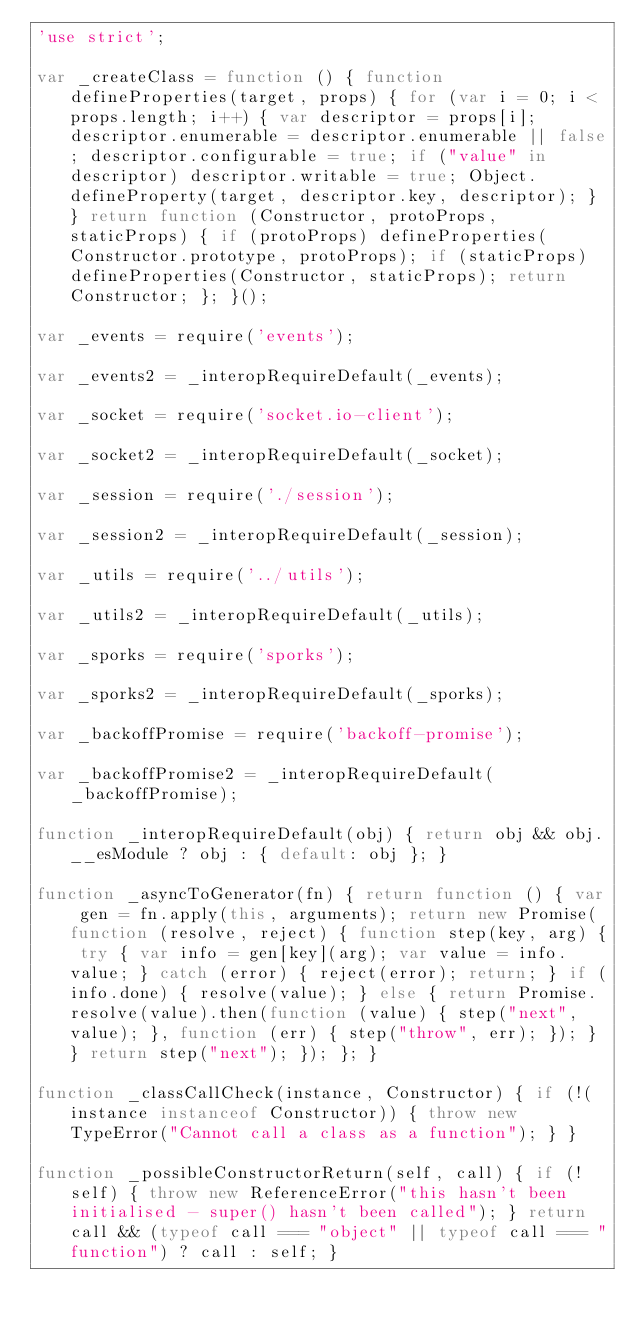Convert code to text. <code><loc_0><loc_0><loc_500><loc_500><_JavaScript_>'use strict';

var _createClass = function () { function defineProperties(target, props) { for (var i = 0; i < props.length; i++) { var descriptor = props[i]; descriptor.enumerable = descriptor.enumerable || false; descriptor.configurable = true; if ("value" in descriptor) descriptor.writable = true; Object.defineProperty(target, descriptor.key, descriptor); } } return function (Constructor, protoProps, staticProps) { if (protoProps) defineProperties(Constructor.prototype, protoProps); if (staticProps) defineProperties(Constructor, staticProps); return Constructor; }; }();

var _events = require('events');

var _events2 = _interopRequireDefault(_events);

var _socket = require('socket.io-client');

var _socket2 = _interopRequireDefault(_socket);

var _session = require('./session');

var _session2 = _interopRequireDefault(_session);

var _utils = require('../utils');

var _utils2 = _interopRequireDefault(_utils);

var _sporks = require('sporks');

var _sporks2 = _interopRequireDefault(_sporks);

var _backoffPromise = require('backoff-promise');

var _backoffPromise2 = _interopRequireDefault(_backoffPromise);

function _interopRequireDefault(obj) { return obj && obj.__esModule ? obj : { default: obj }; }

function _asyncToGenerator(fn) { return function () { var gen = fn.apply(this, arguments); return new Promise(function (resolve, reject) { function step(key, arg) { try { var info = gen[key](arg); var value = info.value; } catch (error) { reject(error); return; } if (info.done) { resolve(value); } else { return Promise.resolve(value).then(function (value) { step("next", value); }, function (err) { step("throw", err); }); } } return step("next"); }); }; }

function _classCallCheck(instance, Constructor) { if (!(instance instanceof Constructor)) { throw new TypeError("Cannot call a class as a function"); } }

function _possibleConstructorReturn(self, call) { if (!self) { throw new ReferenceError("this hasn't been initialised - super() hasn't been called"); } return call && (typeof call === "object" || typeof call === "function") ? call : self; }
</code> 